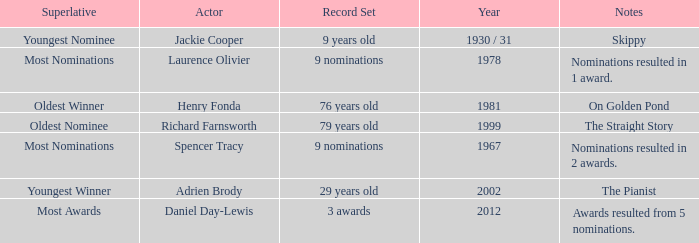What actor won in 1978? Laurence Olivier. 